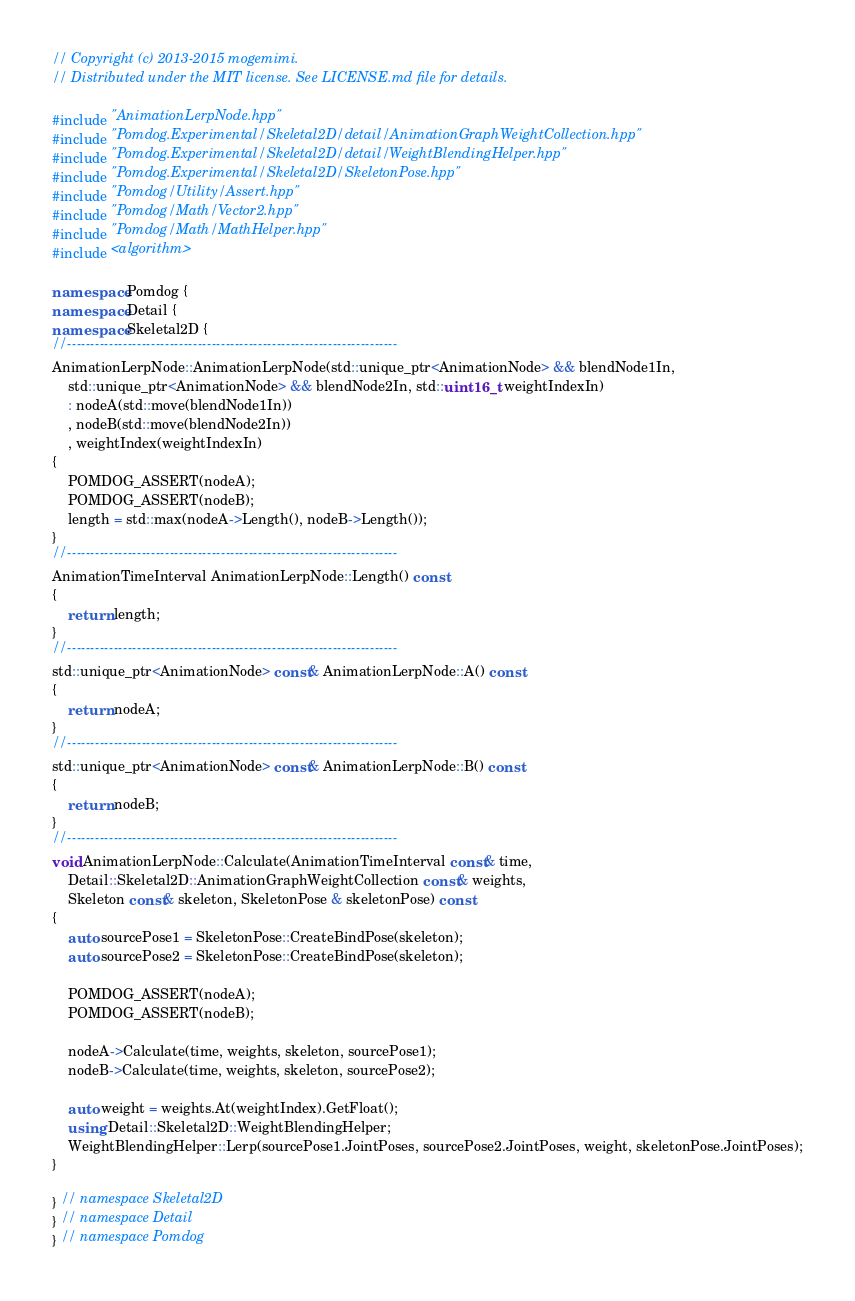<code> <loc_0><loc_0><loc_500><loc_500><_C++_>// Copyright (c) 2013-2015 mogemimi.
// Distributed under the MIT license. See LICENSE.md file for details.

#include "AnimationLerpNode.hpp"
#include "Pomdog.Experimental/Skeletal2D/detail/AnimationGraphWeightCollection.hpp"
#include "Pomdog.Experimental/Skeletal2D/detail/WeightBlendingHelper.hpp"
#include "Pomdog.Experimental/Skeletal2D/SkeletonPose.hpp"
#include "Pomdog/Utility/Assert.hpp"
#include "Pomdog/Math/Vector2.hpp"
#include "Pomdog/Math/MathHelper.hpp"
#include <algorithm>

namespace Pomdog {
namespace Detail {
namespace Skeletal2D {
//-----------------------------------------------------------------------
AnimationLerpNode::AnimationLerpNode(std::unique_ptr<AnimationNode> && blendNode1In,
    std::unique_ptr<AnimationNode> && blendNode2In, std::uint16_t weightIndexIn)
    : nodeA(std::move(blendNode1In))
    , nodeB(std::move(blendNode2In))
    , weightIndex(weightIndexIn)
{
    POMDOG_ASSERT(nodeA);
    POMDOG_ASSERT(nodeB);
    length = std::max(nodeA->Length(), nodeB->Length());
}
//-----------------------------------------------------------------------
AnimationTimeInterval AnimationLerpNode::Length() const
{
    return length;
}
//-----------------------------------------------------------------------
std::unique_ptr<AnimationNode> const& AnimationLerpNode::A() const
{
    return nodeA;
}
//-----------------------------------------------------------------------
std::unique_ptr<AnimationNode> const& AnimationLerpNode::B() const
{
    return nodeB;
}
//-----------------------------------------------------------------------
void AnimationLerpNode::Calculate(AnimationTimeInterval const& time,
    Detail::Skeletal2D::AnimationGraphWeightCollection const& weights,
    Skeleton const& skeleton, SkeletonPose & skeletonPose) const
{
    auto sourcePose1 = SkeletonPose::CreateBindPose(skeleton);
    auto sourcePose2 = SkeletonPose::CreateBindPose(skeleton);

    POMDOG_ASSERT(nodeA);
    POMDOG_ASSERT(nodeB);

    nodeA->Calculate(time, weights, skeleton, sourcePose1);
    nodeB->Calculate(time, weights, skeleton, sourcePose2);

    auto weight = weights.At(weightIndex).GetFloat();
    using Detail::Skeletal2D::WeightBlendingHelper;
    WeightBlendingHelper::Lerp(sourcePose1.JointPoses, sourcePose2.JointPoses, weight, skeletonPose.JointPoses);
}

} // namespace Skeletal2D
} // namespace Detail
} // namespace Pomdog
</code> 